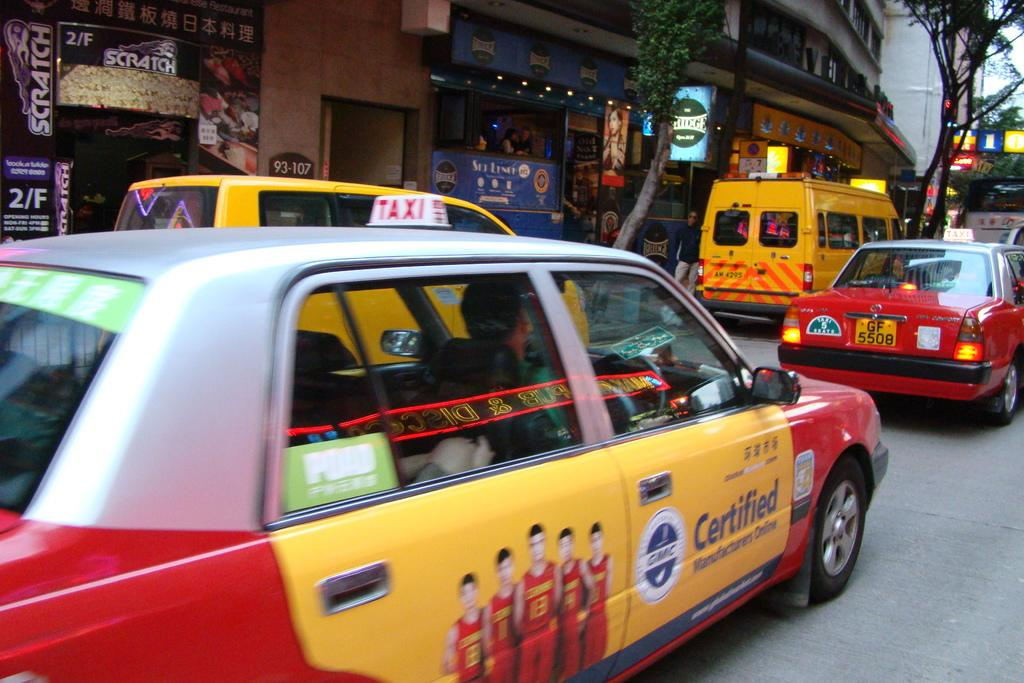<image>
Summarize the visual content of the image. a taxi parked outside in front of the scratch storefront 